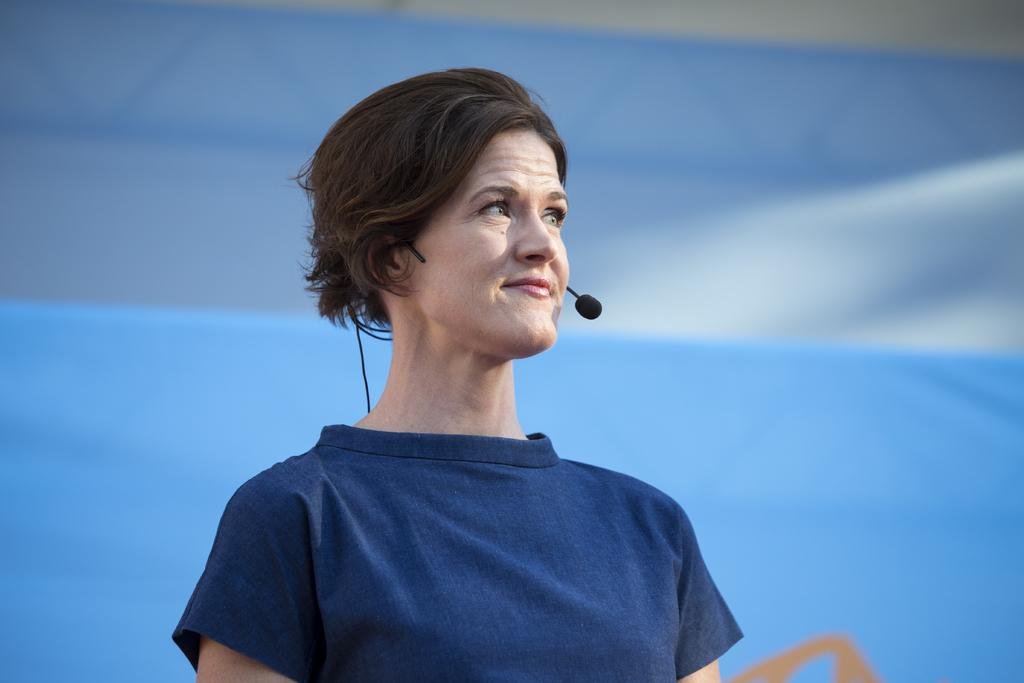Who is the main subject in the image? There is a woman in the image. What is the woman wearing in the image? The woman is wearing a mic in the image. What can be seen in the background of the image? There is a banner and a wall in the background of the image. What type of mint plant is growing on the wall in the image? There is no mint plant visible in the image; the wall is part of the background and does not have any plants growing on it. 